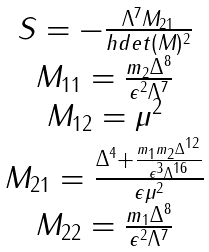Convert formula to latex. <formula><loc_0><loc_0><loc_500><loc_500>\begin{array} { c } S = - \frac { \Lambda ^ { 7 } M _ { 2 1 } } { h d e t ( M ) ^ { 2 } } \\ M _ { 1 1 } = \frac { m _ { 2 } \Delta ^ { 8 } } { \epsilon ^ { 2 } \Lambda ^ { 7 } } \\ M _ { 1 2 } = \mu ^ { 2 } \\ M _ { 2 1 } = \frac { \Delta ^ { 4 } + \frac { m _ { 1 } m _ { 2 } \Delta ^ { 1 2 } } { \epsilon ^ { 3 } \Lambda ^ { 1 6 } } } { \epsilon \mu ^ { 2 } } \\ M _ { 2 2 } = \frac { m _ { 1 } \Delta ^ { 8 } } { \epsilon ^ { 2 } \Lambda ^ { 7 } } \\ \end{array}</formula> 